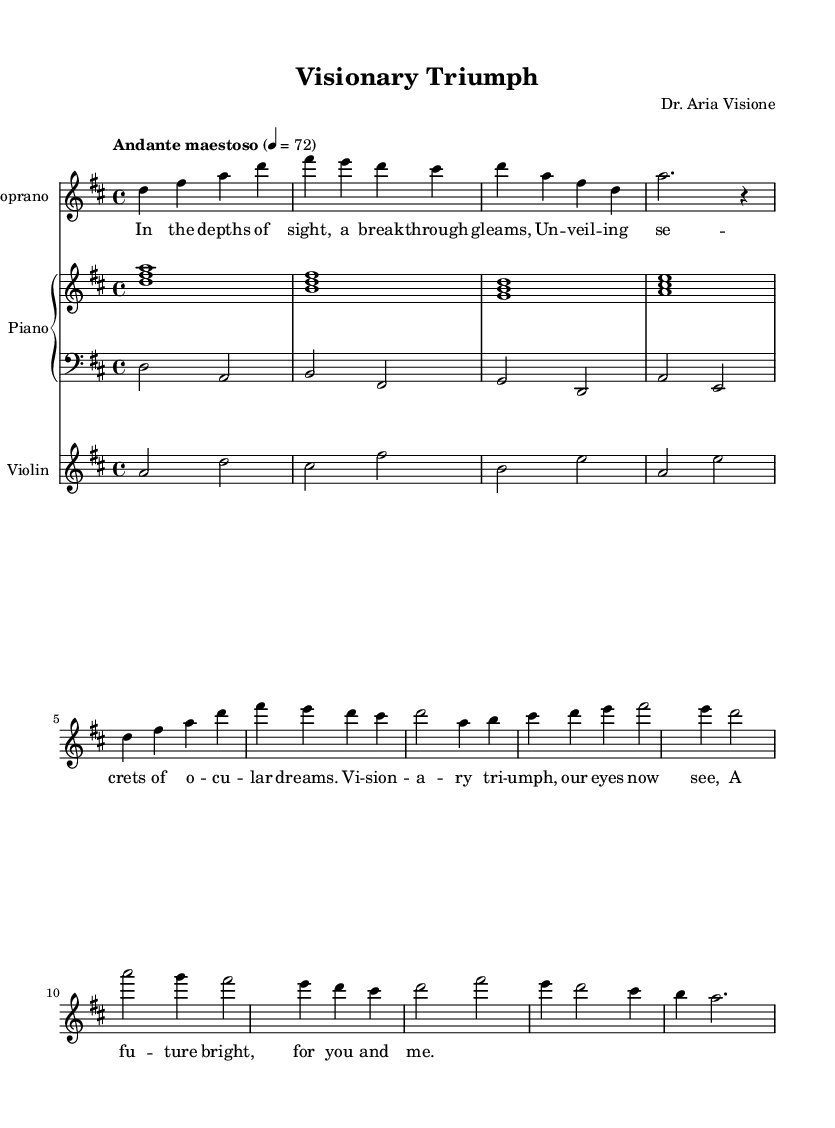What is the key signature of this music? The key signature is indicated by the presence of two sharps, which correspond to F# and C#. This suggests the piece is in D major.
Answer: D major What is the time signature? The time signature is displayed as a fraction at the beginning of the score; it reads 4 over 4, which indicates that there are four beats in each measure and the quarter note receives one beat.
Answer: 4/4 What is the tempo marking for this piece? The tempo marking is found at the beginning, stating "Andante maestoso," which describes the speed and character of the music. "Andante" typically indicates a moderately slow tempo, and "maestoso" suggests a majestic quality.
Answer: Andante maestoso How many measures are present in the soprano part? By counting the grouped notes and bars in the soprano section, we can see there are a total of 7 measures that include both the introduction and the verse.
Answer: 7 What is the vocal range specified for the soprano part? The soprano part begins with a clef marking of treble, and the notes range from D in a higher octave down to A in a lower octave, indicating it covers a typical soprano range extending over an octave.
Answer: Soprano What type of instrumental accompaniment is present in this score? The score contains a piano staff, indicating that the accompaniment is provided for piano as well as a violin part, which enhances the orchestral texture typical in opera.
Answer: Piano and violin 